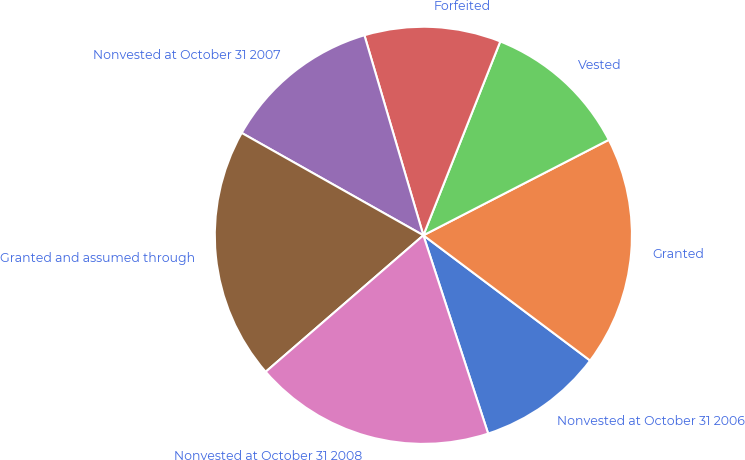Convert chart to OTSL. <chart><loc_0><loc_0><loc_500><loc_500><pie_chart><fcel>Nonvested at October 31 2006<fcel>Granted<fcel>Vested<fcel>Forfeited<fcel>Nonvested at October 31 2007<fcel>Granted and assumed through<fcel>Nonvested at October 31 2008<nl><fcel>9.72%<fcel>17.82%<fcel>11.42%<fcel>10.57%<fcel>12.27%<fcel>19.52%<fcel>18.67%<nl></chart> 